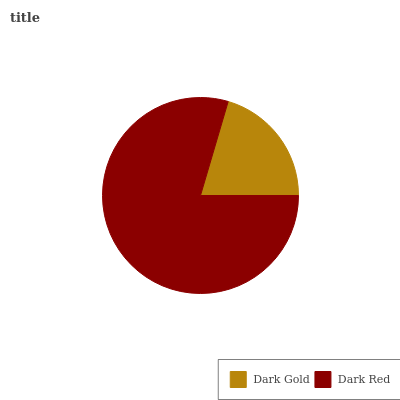Is Dark Gold the minimum?
Answer yes or no. Yes. Is Dark Red the maximum?
Answer yes or no. Yes. Is Dark Red the minimum?
Answer yes or no. No. Is Dark Red greater than Dark Gold?
Answer yes or no. Yes. Is Dark Gold less than Dark Red?
Answer yes or no. Yes. Is Dark Gold greater than Dark Red?
Answer yes or no. No. Is Dark Red less than Dark Gold?
Answer yes or no. No. Is Dark Red the high median?
Answer yes or no. Yes. Is Dark Gold the low median?
Answer yes or no. Yes. Is Dark Gold the high median?
Answer yes or no. No. Is Dark Red the low median?
Answer yes or no. No. 